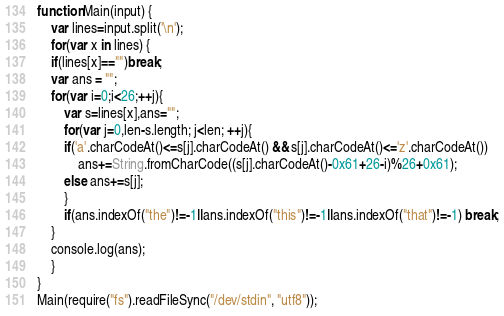<code> <loc_0><loc_0><loc_500><loc_500><_JavaScript_>function Main(input) {
    var lines=input.split('\n');
    for(var x in lines) {
	if(lines[x]=="")break;
	var ans = "";
	for(var i=0;i<26;++j){
	    var s=lines[x],ans="";
	    for(var j=0,len-s.length; j<len; ++j){
		if('a'.charCodeAt()<=s[j].charCodeAt() && s[j].charCodeAt()<='z'.charCodeAt())
		    ans+=String.fromCharCode((s[j].charCodeAt()-0x61+26-i)%26+0x61);
		else ans+=s[j];
	    }
	    if(ans.indexOf("the")!=-1||ans.indexOf("this")!=-1||ans.indexOf("that")!=-1) break;
	}
	console.log(ans);
    }
}
Main(require("fs").readFileSync("/dev/stdin", "utf8"));</code> 